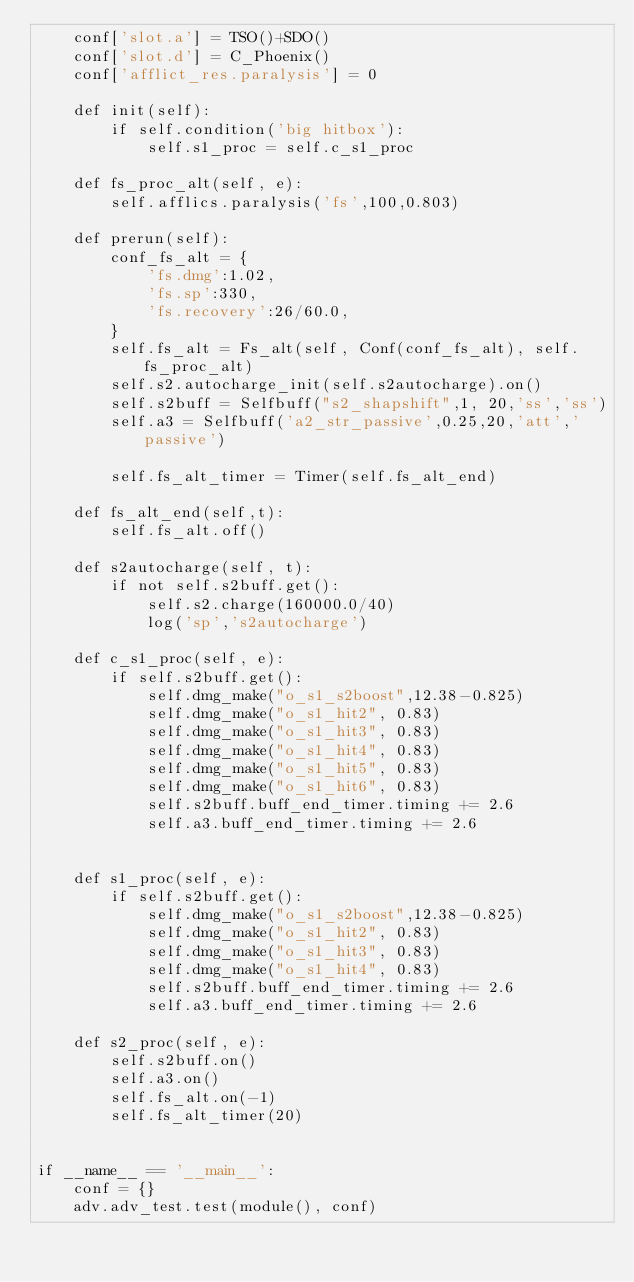Convert code to text. <code><loc_0><loc_0><loc_500><loc_500><_Python_>    conf['slot.a'] = TSO()+SDO()
    conf['slot.d'] = C_Phoenix()
    conf['afflict_res.paralysis'] = 0

    def init(self):
        if self.condition('big hitbox'):
            self.s1_proc = self.c_s1_proc

    def fs_proc_alt(self, e):
        self.afflics.paralysis('fs',100,0.803)

    def prerun(self):
        conf_fs_alt = {
            'fs.dmg':1.02,
            'fs.sp':330,
            'fs.recovery':26/60.0,
        }
        self.fs_alt = Fs_alt(self, Conf(conf_fs_alt), self.fs_proc_alt)
        self.s2.autocharge_init(self.s2autocharge).on()
        self.s2buff = Selfbuff("s2_shapshift",1, 20,'ss','ss')
        self.a3 = Selfbuff('a2_str_passive',0.25,20,'att','passive')

        self.fs_alt_timer = Timer(self.fs_alt_end)

    def fs_alt_end(self,t):
        self.fs_alt.off()

    def s2autocharge(self, t):
        if not self.s2buff.get():
            self.s2.charge(160000.0/40)
            log('sp','s2autocharge')

    def c_s1_proc(self, e):
        if self.s2buff.get():
            self.dmg_make("o_s1_s2boost",12.38-0.825)
            self.dmg_make("o_s1_hit2", 0.83)
            self.dmg_make("o_s1_hit3", 0.83)
            self.dmg_make("o_s1_hit4", 0.83)
            self.dmg_make("o_s1_hit5", 0.83)
            self.dmg_make("o_s1_hit6", 0.83)
            self.s2buff.buff_end_timer.timing += 2.6
            self.a3.buff_end_timer.timing += 2.6


    def s1_proc(self, e):
        if self.s2buff.get():
            self.dmg_make("o_s1_s2boost",12.38-0.825)
            self.dmg_make("o_s1_hit2", 0.83)
            self.dmg_make("o_s1_hit3", 0.83)
            self.dmg_make("o_s1_hit4", 0.83)
            self.s2buff.buff_end_timer.timing += 2.6
            self.a3.buff_end_timer.timing += 2.6

    def s2_proc(self, e):
        self.s2buff.on()
        self.a3.on()
        self.fs_alt.on(-1)
        self.fs_alt_timer(20)


if __name__ == '__main__':
    conf = {}
    adv.adv_test.test(module(), conf)

</code> 